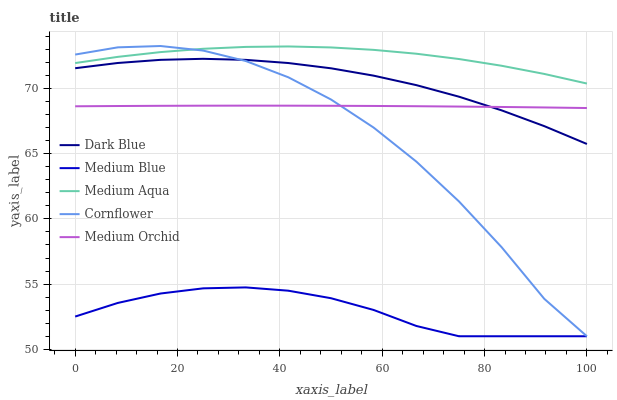Does Dark Blue have the minimum area under the curve?
Answer yes or no. No. Does Dark Blue have the maximum area under the curve?
Answer yes or no. No. Is Dark Blue the smoothest?
Answer yes or no. No. Is Dark Blue the roughest?
Answer yes or no. No. Does Dark Blue have the lowest value?
Answer yes or no. No. Does Dark Blue have the highest value?
Answer yes or no. No. Is Medium Orchid less than Medium Aqua?
Answer yes or no. Yes. Is Medium Aqua greater than Medium Orchid?
Answer yes or no. Yes. Does Medium Orchid intersect Medium Aqua?
Answer yes or no. No. 